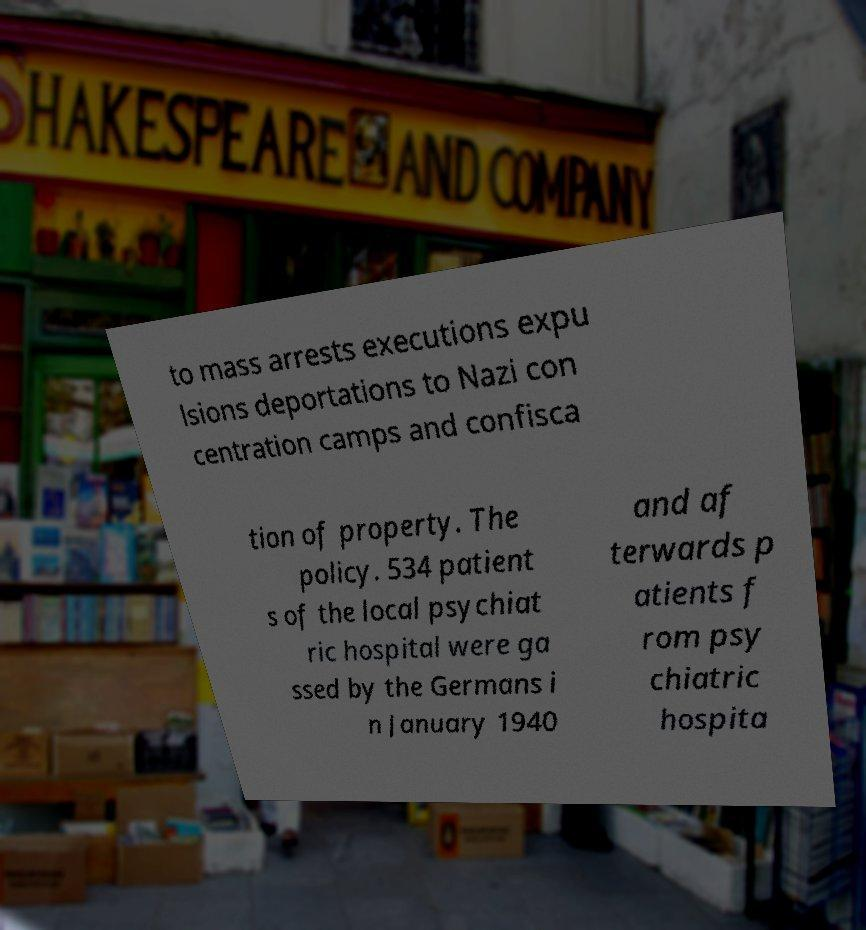Could you extract and type out the text from this image? to mass arrests executions expu lsions deportations to Nazi con centration camps and confisca tion of property. The policy. 534 patient s of the local psychiat ric hospital were ga ssed by the Germans i n January 1940 and af terwards p atients f rom psy chiatric hospita 